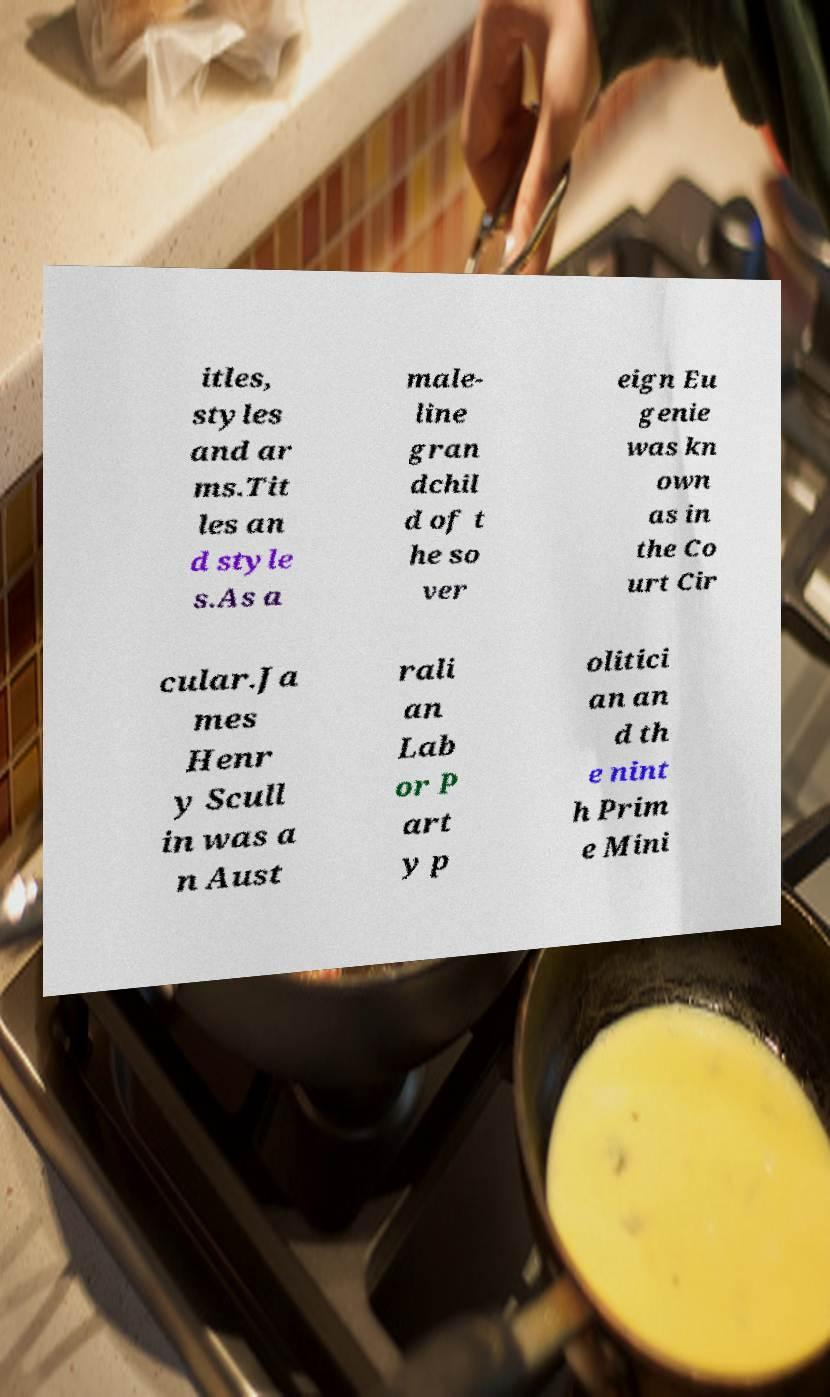What messages or text are displayed in this image? I need them in a readable, typed format. itles, styles and ar ms.Tit les an d style s.As a male- line gran dchil d of t he so ver eign Eu genie was kn own as in the Co urt Cir cular.Ja mes Henr y Scull in was a n Aust rali an Lab or P art y p olitici an an d th e nint h Prim e Mini 